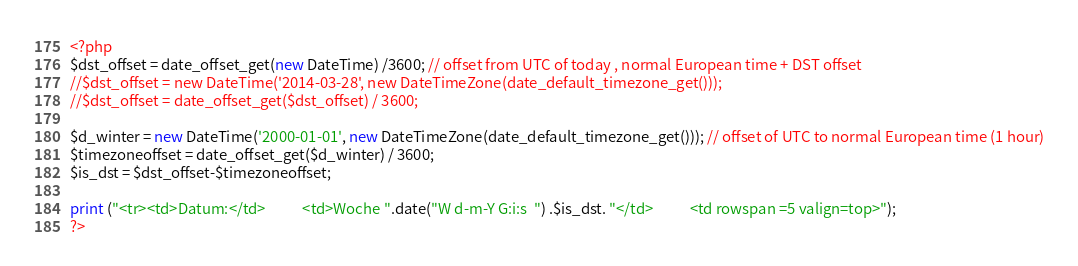Convert code to text. <code><loc_0><loc_0><loc_500><loc_500><_PHP_>
<?php
$dst_offset = date_offset_get(new DateTime) /3600; // offset from UTC of today , normal European time + DST offset
//$dst_offset = new DateTime('2014-03-28', new DateTimeZone(date_default_timezone_get()));
//$dst_offset = date_offset_get($dst_offset) / 3600;

$d_winter = new DateTime('2000-01-01', new DateTimeZone(date_default_timezone_get())); // offset of UTC to normal European time (1 hour)
$timezoneoffset = date_offset_get($d_winter) / 3600;
$is_dst = $dst_offset-$timezoneoffset;
 
print ("<tr><td>Datum:</td>           <td>Woche ".date("W d-m-Y G:i:s  ") .$is_dst. "</td>           <td rowspan =5 valign=top>"); 
?></code> 